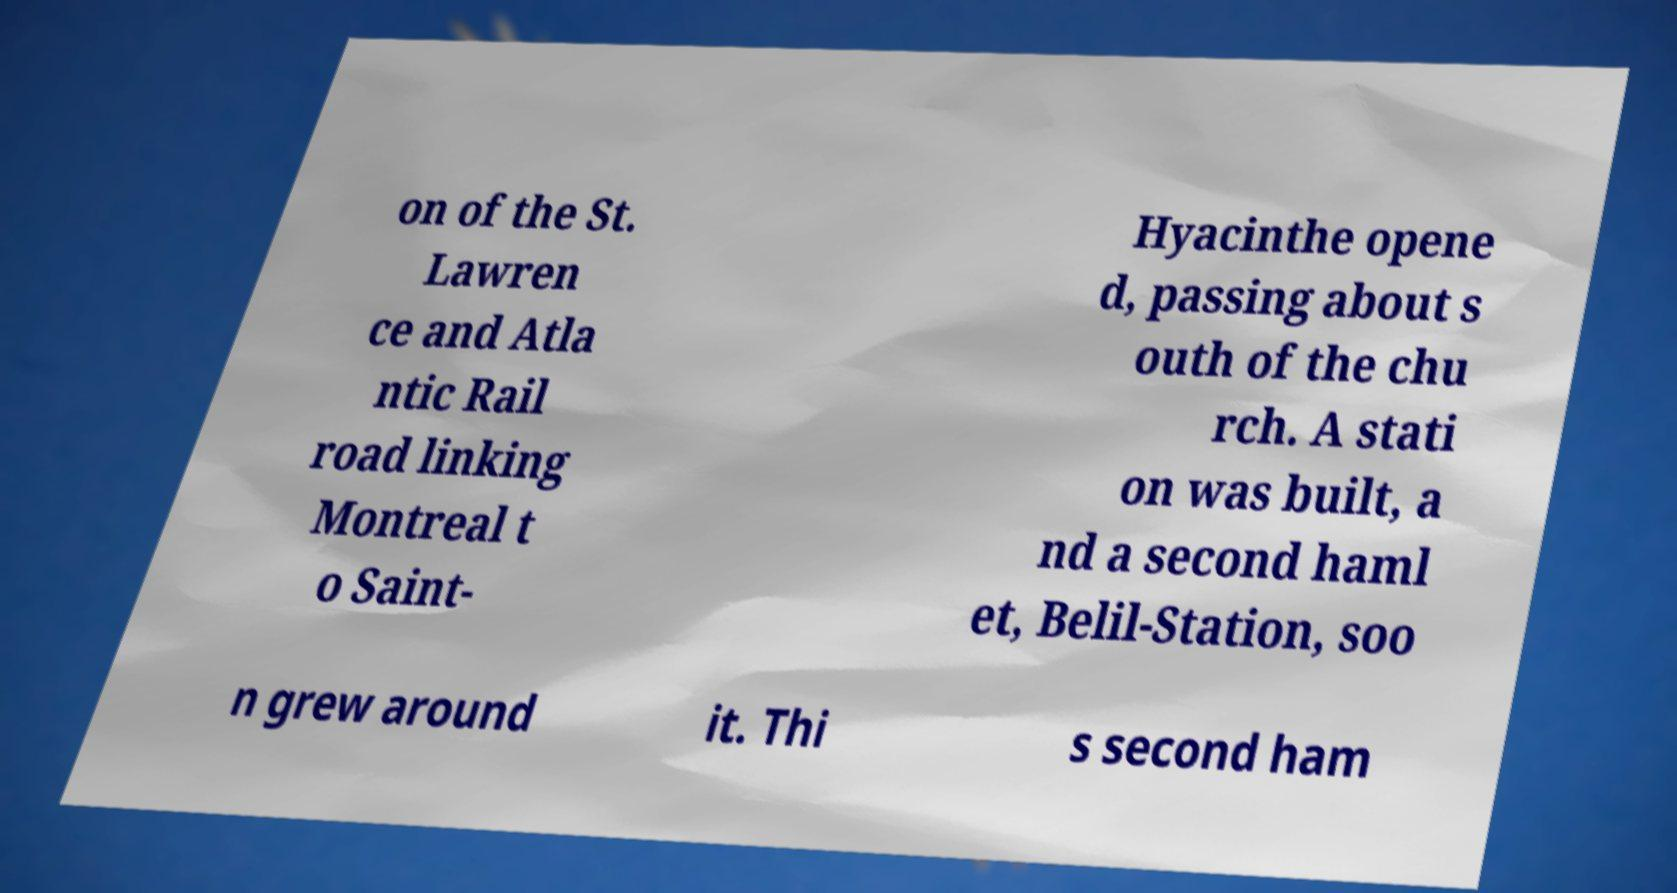I need the written content from this picture converted into text. Can you do that? on of the St. Lawren ce and Atla ntic Rail road linking Montreal t o Saint- Hyacinthe opene d, passing about s outh of the chu rch. A stati on was built, a nd a second haml et, Belil-Station, soo n grew around it. Thi s second ham 